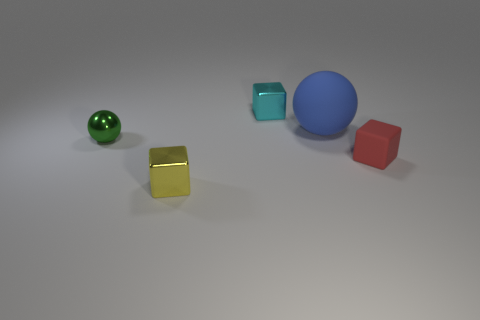What number of tiny metal objects have the same color as the tiny ball?
Your response must be concise. 0. The cyan thing that is the same material as the green thing is what size?
Give a very brief answer. Small. What size is the sphere on the left side of the small shiny block to the right of the tiny metal thing that is in front of the rubber block?
Offer a terse response. Small. There is a block that is to the right of the matte sphere; what size is it?
Provide a succinct answer. Small. How many yellow things are small metal things or shiny spheres?
Give a very brief answer. 1. Are there any green objects that have the same size as the blue matte thing?
Ensure brevity in your answer.  No. What is the material of the green thing that is the same size as the yellow metal thing?
Ensure brevity in your answer.  Metal. Do the shiny block behind the red rubber object and the thing in front of the small matte thing have the same size?
Provide a short and direct response. Yes. How many objects are tiny cyan cubes or blocks that are on the left side of the small matte thing?
Your answer should be compact. 2. Is there a small object of the same shape as the large matte object?
Offer a terse response. Yes. 